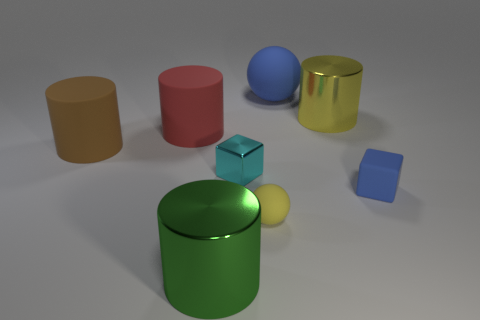Subtract all yellow metallic cylinders. How many cylinders are left? 3 Add 2 small blue things. How many objects exist? 10 Subtract all cubes. How many objects are left? 6 Subtract 1 cubes. How many cubes are left? 1 Subtract all brown spheres. Subtract all blue cylinders. How many spheres are left? 2 Subtract all red spheres. How many gray cubes are left? 0 Subtract all large blue rubber balls. Subtract all small blue things. How many objects are left? 6 Add 3 tiny matte blocks. How many tiny matte blocks are left? 4 Add 3 large yellow metal things. How many large yellow metal things exist? 4 Subtract all green cylinders. How many cylinders are left? 3 